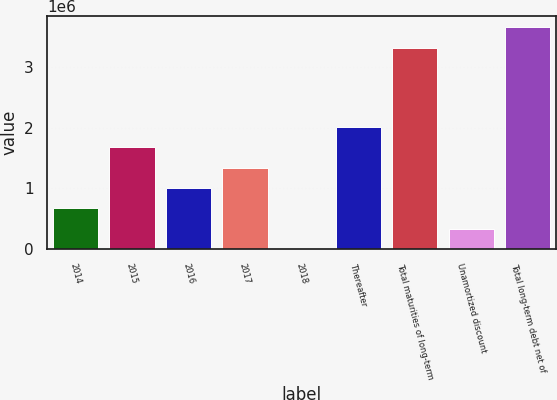Convert chart. <chart><loc_0><loc_0><loc_500><loc_500><bar_chart><fcel>2014<fcel>2015<fcel>2016<fcel>2017<fcel>2018<fcel>Thereafter<fcel>Total maturities of long-term<fcel>Unamortized discount<fcel>Total long-term debt net of<nl><fcel>670844<fcel>1.67709e+06<fcel>1.00626e+06<fcel>1.34168e+06<fcel>12<fcel>2.01251e+06<fcel>3.31821e+06<fcel>335428<fcel>3.65362e+06<nl></chart> 